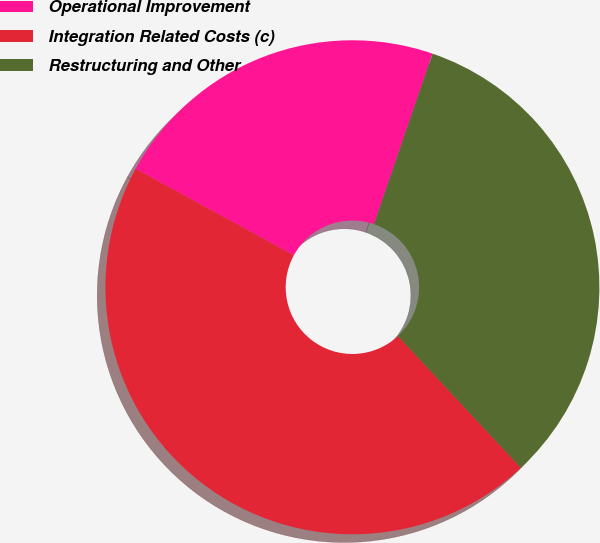Convert chart. <chart><loc_0><loc_0><loc_500><loc_500><pie_chart><fcel>Operational Improvement<fcel>Integration Related Costs (c)<fcel>Restructuring and Other<nl><fcel>22.31%<fcel>44.91%<fcel>32.79%<nl></chart> 